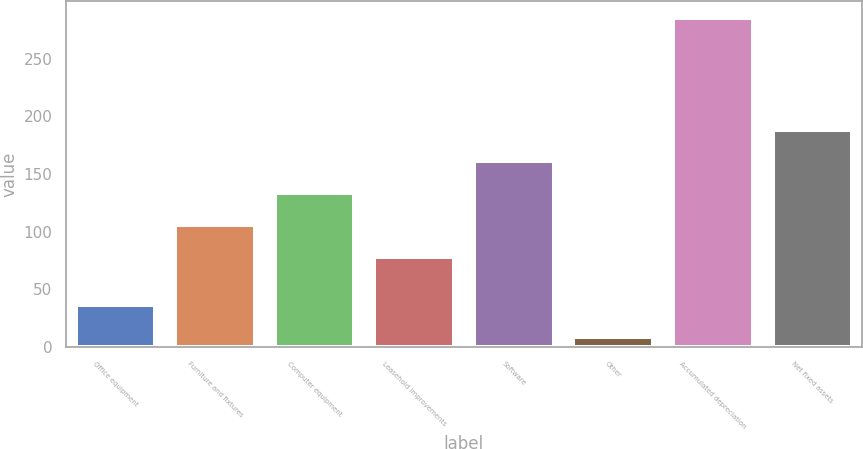<chart> <loc_0><loc_0><loc_500><loc_500><bar_chart><fcel>Office equipment<fcel>Furniture and fixtures<fcel>Computer equipment<fcel>Leasehold improvements<fcel>Software<fcel>Other<fcel>Accumulated depreciation<fcel>Net fixed assets<nl><fcel>36.19<fcel>105.59<fcel>133.28<fcel>77.9<fcel>160.97<fcel>8.5<fcel>285.4<fcel>188.66<nl></chart> 